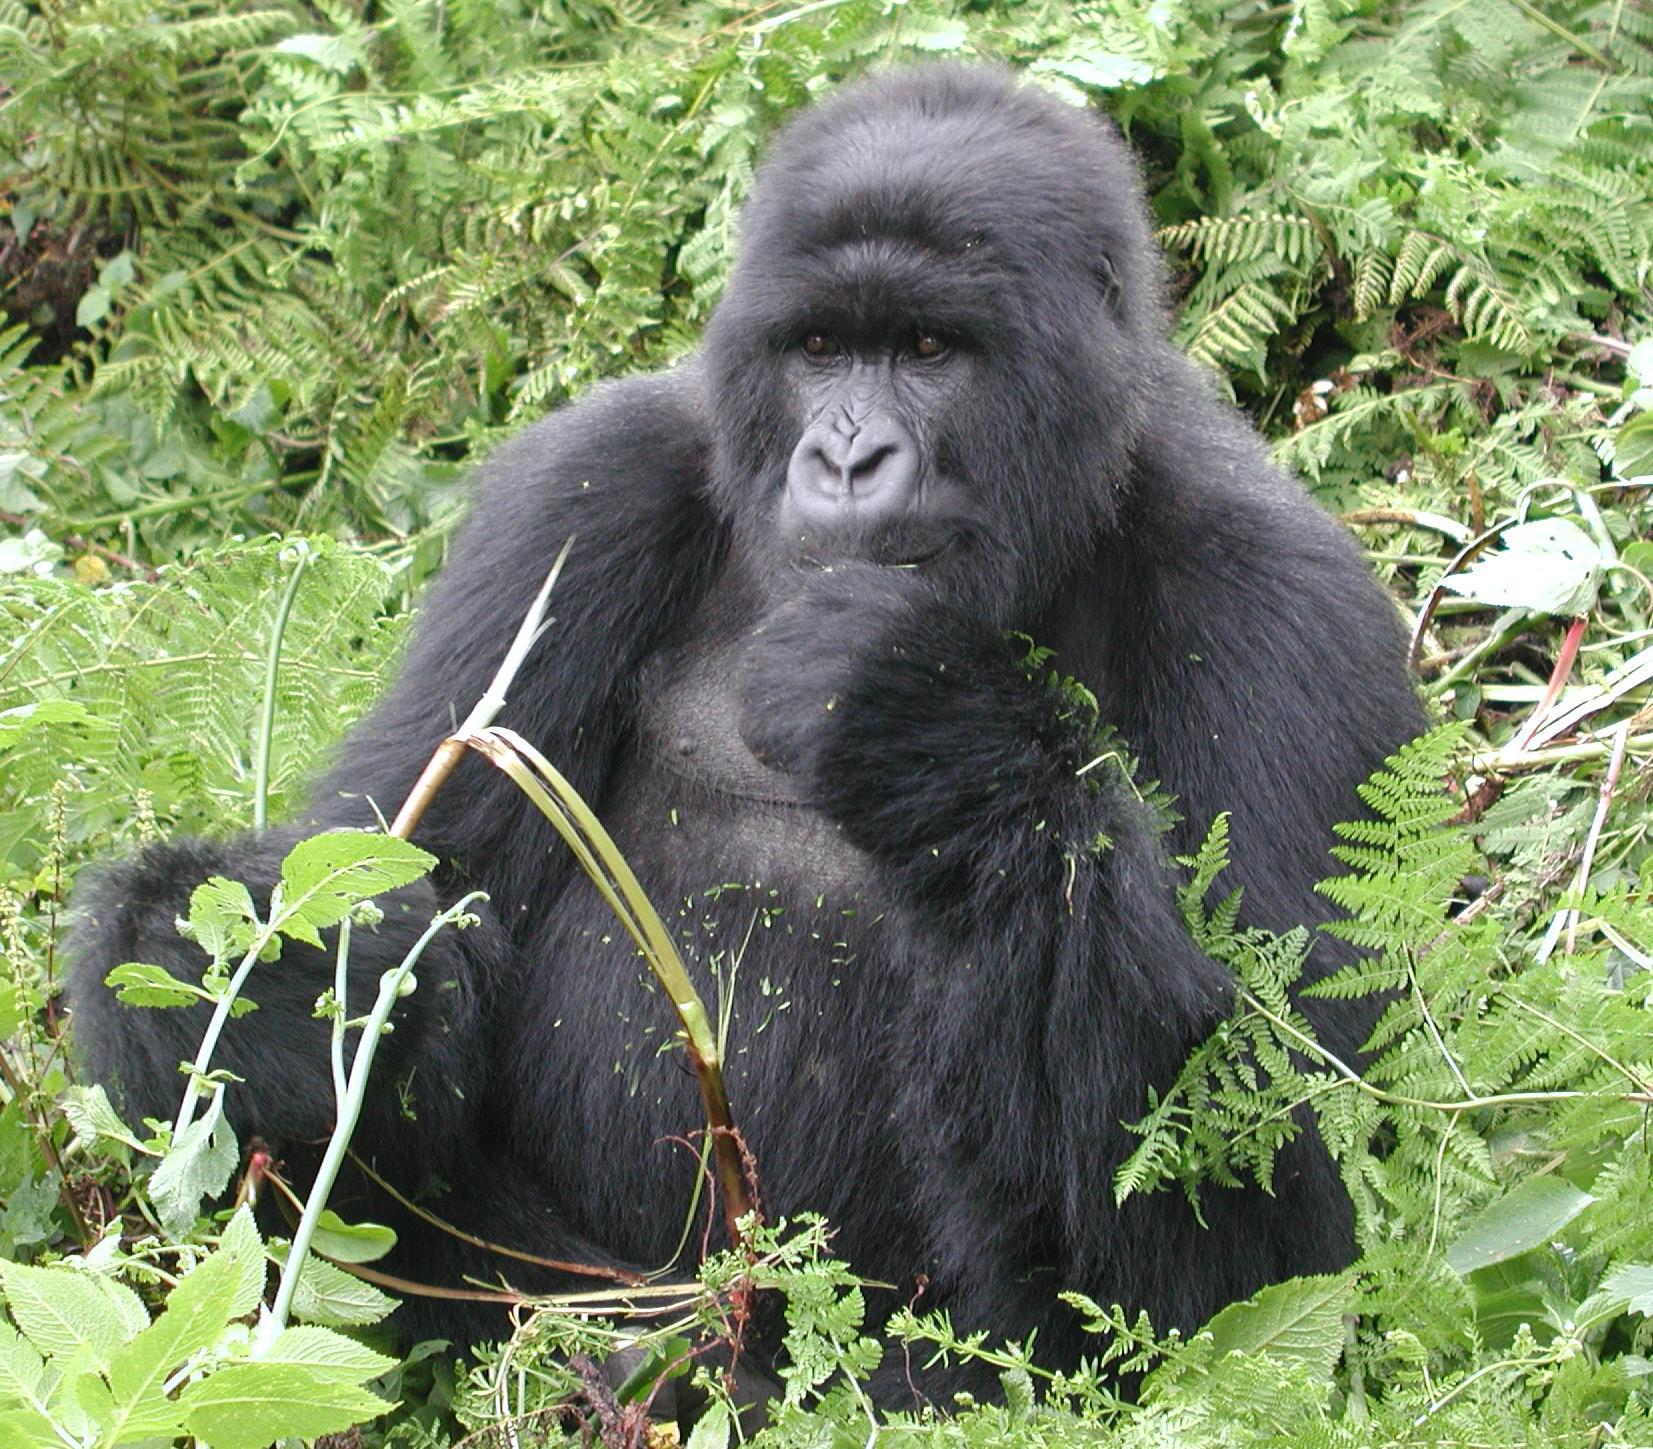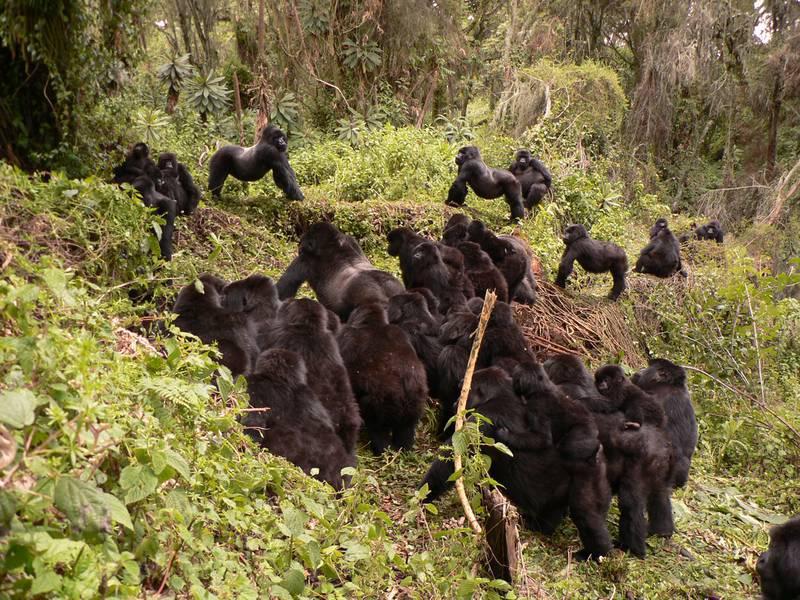The first image is the image on the left, the second image is the image on the right. Examine the images to the left and right. Is the description "There are more than two gorillas in each image." accurate? Answer yes or no. No. The first image is the image on the left, the second image is the image on the right. Examine the images to the left and right. Is the description "There are three black and grey adult gorillas on the ground with only baby gorilla visible." accurate? Answer yes or no. No. 